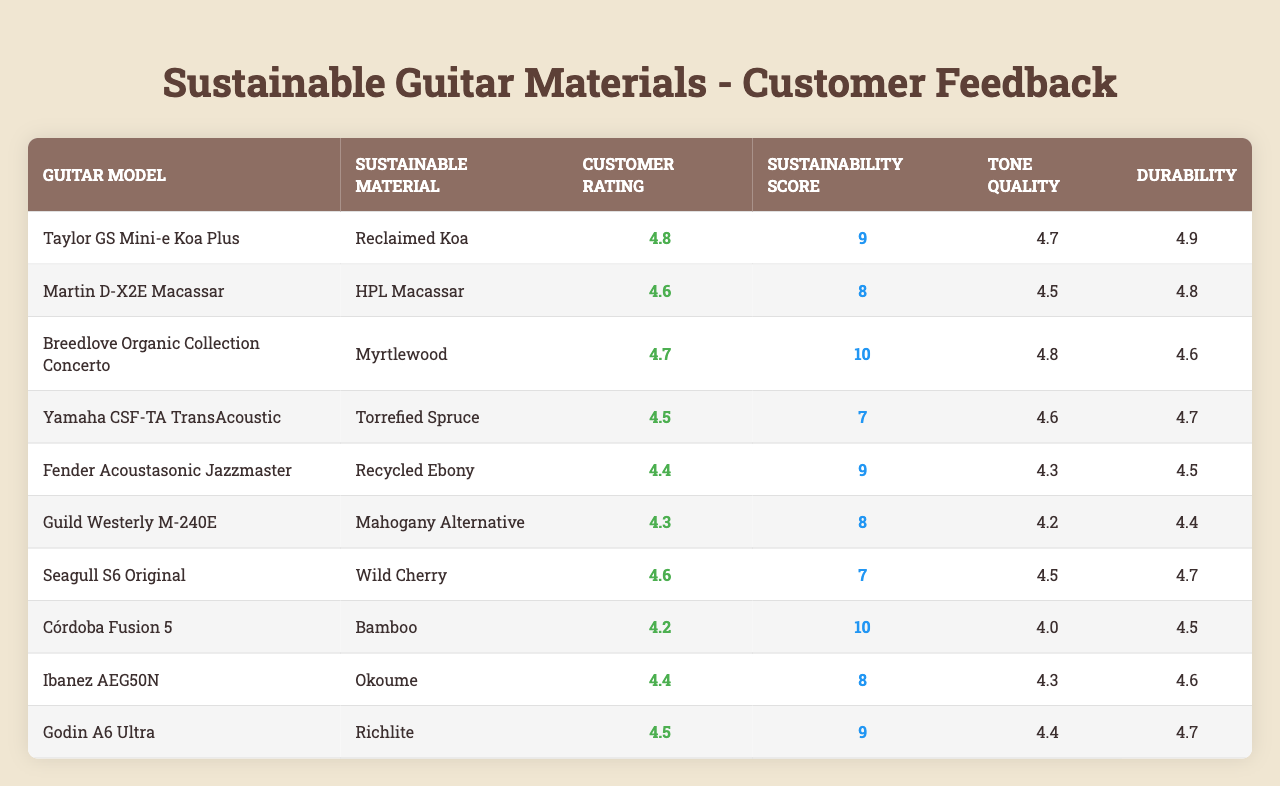What is the highest Customer Rating in the table? The highest Customer Rating listed for any guitar model in the table is 4.8, which belongs to the Taylor GS Mini-e Koa Plus.
Answer: 4.8 Which guitar has the best Sustainability Score? The Best Sustainability Score is 10, which is achieved by both the Breedlove Organic Collection Concerto and the Córdoba Fusion 5.
Answer: 10 What is the average Customer Rating for all guitars listed? To find the average Customer Rating, add the ratings (4.8 + 4.6 + 4.7 + 4.5 + 4.4 + 4.3 + 4.6 + 4.2 + 4.4 + 4.5 = 46.6) and divide by the number of guitars (10). Thus, the average is 46.6/10 = 4.66.
Answer: 4.66 Is there a guitar model with a Customer Rating of 4.5 or lower? Yes, the Fender Acoustasonic Jazzmaster (4.4), the Guild Westerly M-240E (4.3), and the Córdoba Fusion 5 (4.2) have Customer Ratings of 4.5 or lower.
Answer: Yes Which guitar model has the highest Tone Quality rating, and what is that rating? The Breedlove Organic Collection Concerto has the highest Tone Quality rating of 4.8.
Answer: Breedlove Organic Collection Concerto, 4.8 How does the Durability rating of the Taylor GS Mini-e Koa Plus compare to that of the Yamaha CSF-TA TransAcoustic? The Durability rating of the Taylor GS Mini-e Koa Plus is 4.9, while the Durability rating of the Yamaha CSF-TA TransAcoustic is 4.7. Hence, Taylor's is higher by 0.2.
Answer: 0.2 (Taylor GS Mini-e Koa Plus is higher) Are there any guitars made from Bamboo with a Customer Rating above 4.0? Yes, the Córdoba Fusion 5 made from Bamboo has a Customer Rating of 4.2, which is above 4.0.
Answer: Yes Which sustainable material has the lowest average Customer Rating among the listed guitars? First, we calculate the average Customer Rating for guitars made from HPL Macassar (4.6), Mahogany Alternative (4.3), and Bamboo (4.2). The lowest average is for Mahogany Alternative at 4.3.
Answer: Mahogany Alternative What is the difference between the highest and lowest Durability ratings in the table? The highest Durability rating is 4.9 (Taylor GS Mini-e Koa Plus) and the lowest is 4.2 (Mahogany Alternative). The difference is 4.9 - 4.2 = 0.7.
Answer: 0.7 Does the Seagull S6 Original have a higher Sustainability Score than the Guild Westerly M-240E? Yes, the Seagull S6 Original has a Sustainability Score of 7, while the Guild Westerly M-240E has a score of 8, making the Guild's score higher.
Answer: No 